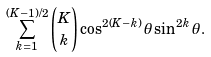Convert formula to latex. <formula><loc_0><loc_0><loc_500><loc_500>\sum _ { k = 1 } ^ { ( K - 1 ) / 2 } { K \choose k } \cos ^ { 2 ( K - k ) } \theta \sin ^ { 2 k } \theta .</formula> 